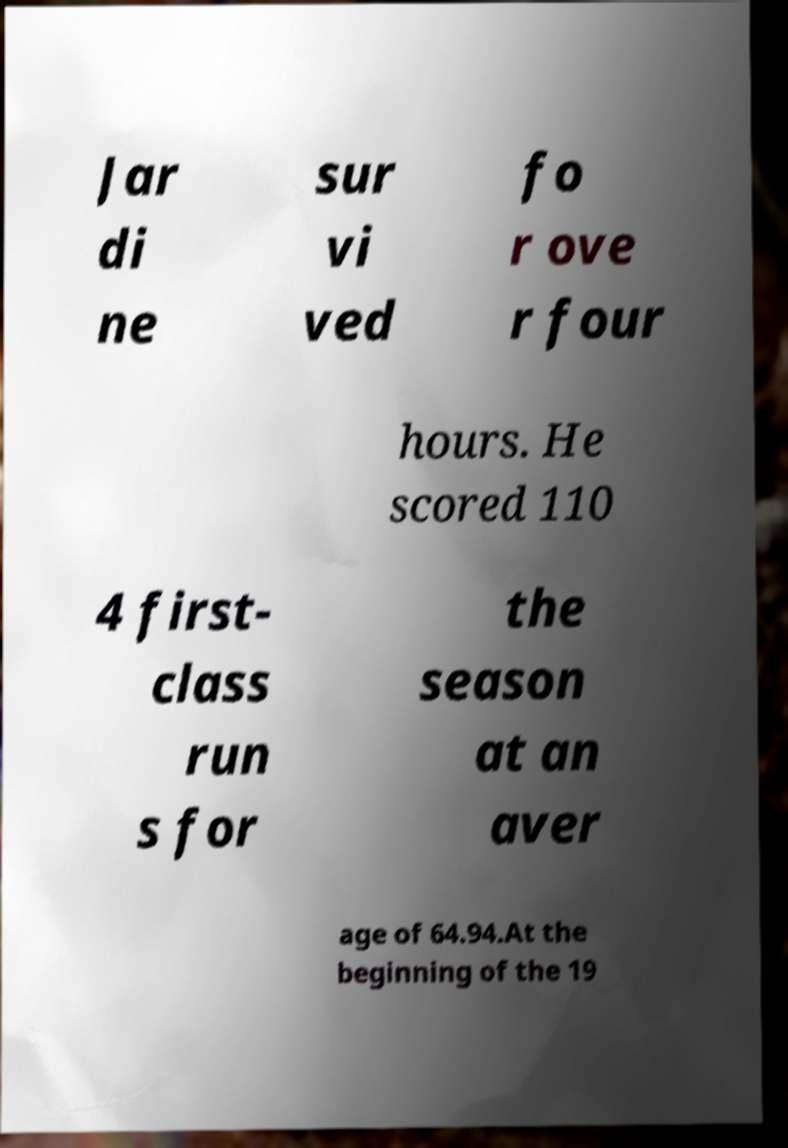Please identify and transcribe the text found in this image. Jar di ne sur vi ved fo r ove r four hours. He scored 110 4 first- class run s for the season at an aver age of 64.94.At the beginning of the 19 